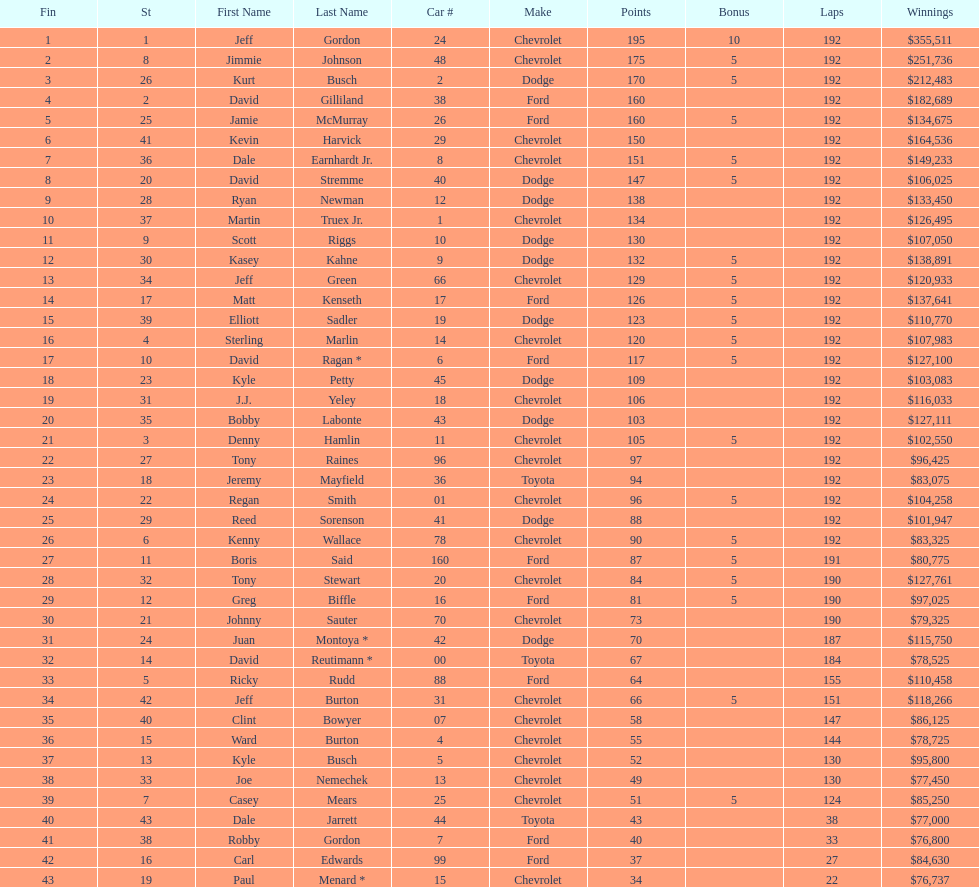How many race car drivers out of the 43 listed drove toyotas? 3. 